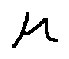Convert formula to latex. <formula><loc_0><loc_0><loc_500><loc_500>\mu</formula> 